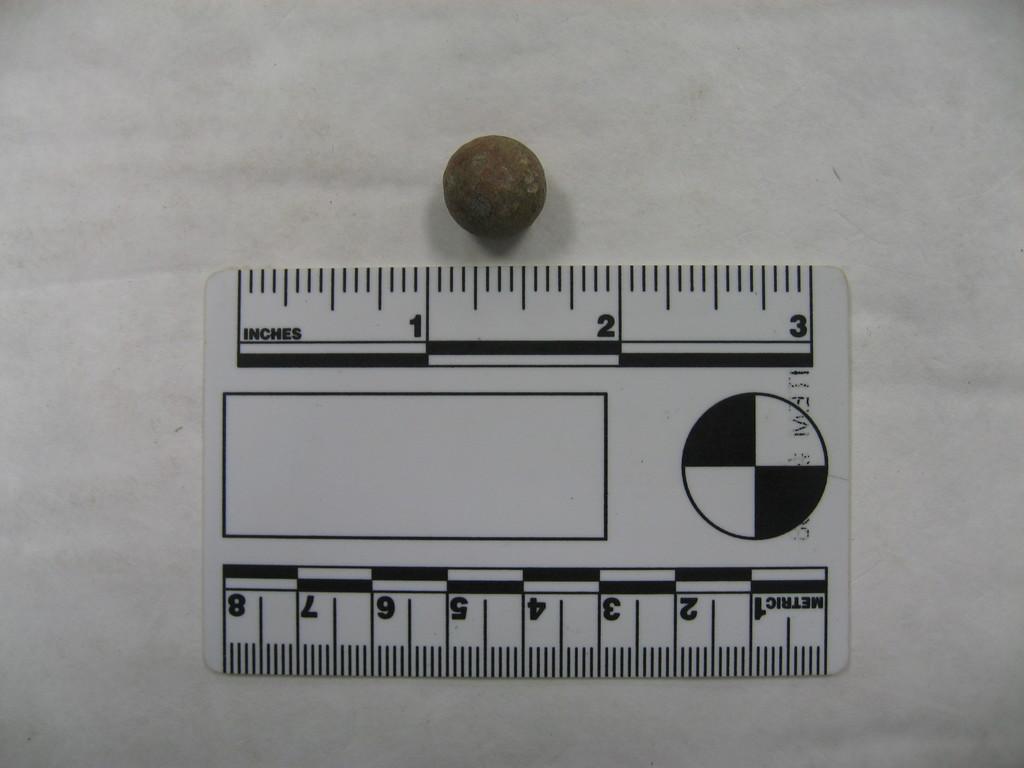What is the left most upper number?
Ensure brevity in your answer.  1. What is the most upper right number?
Give a very brief answer. 3. 